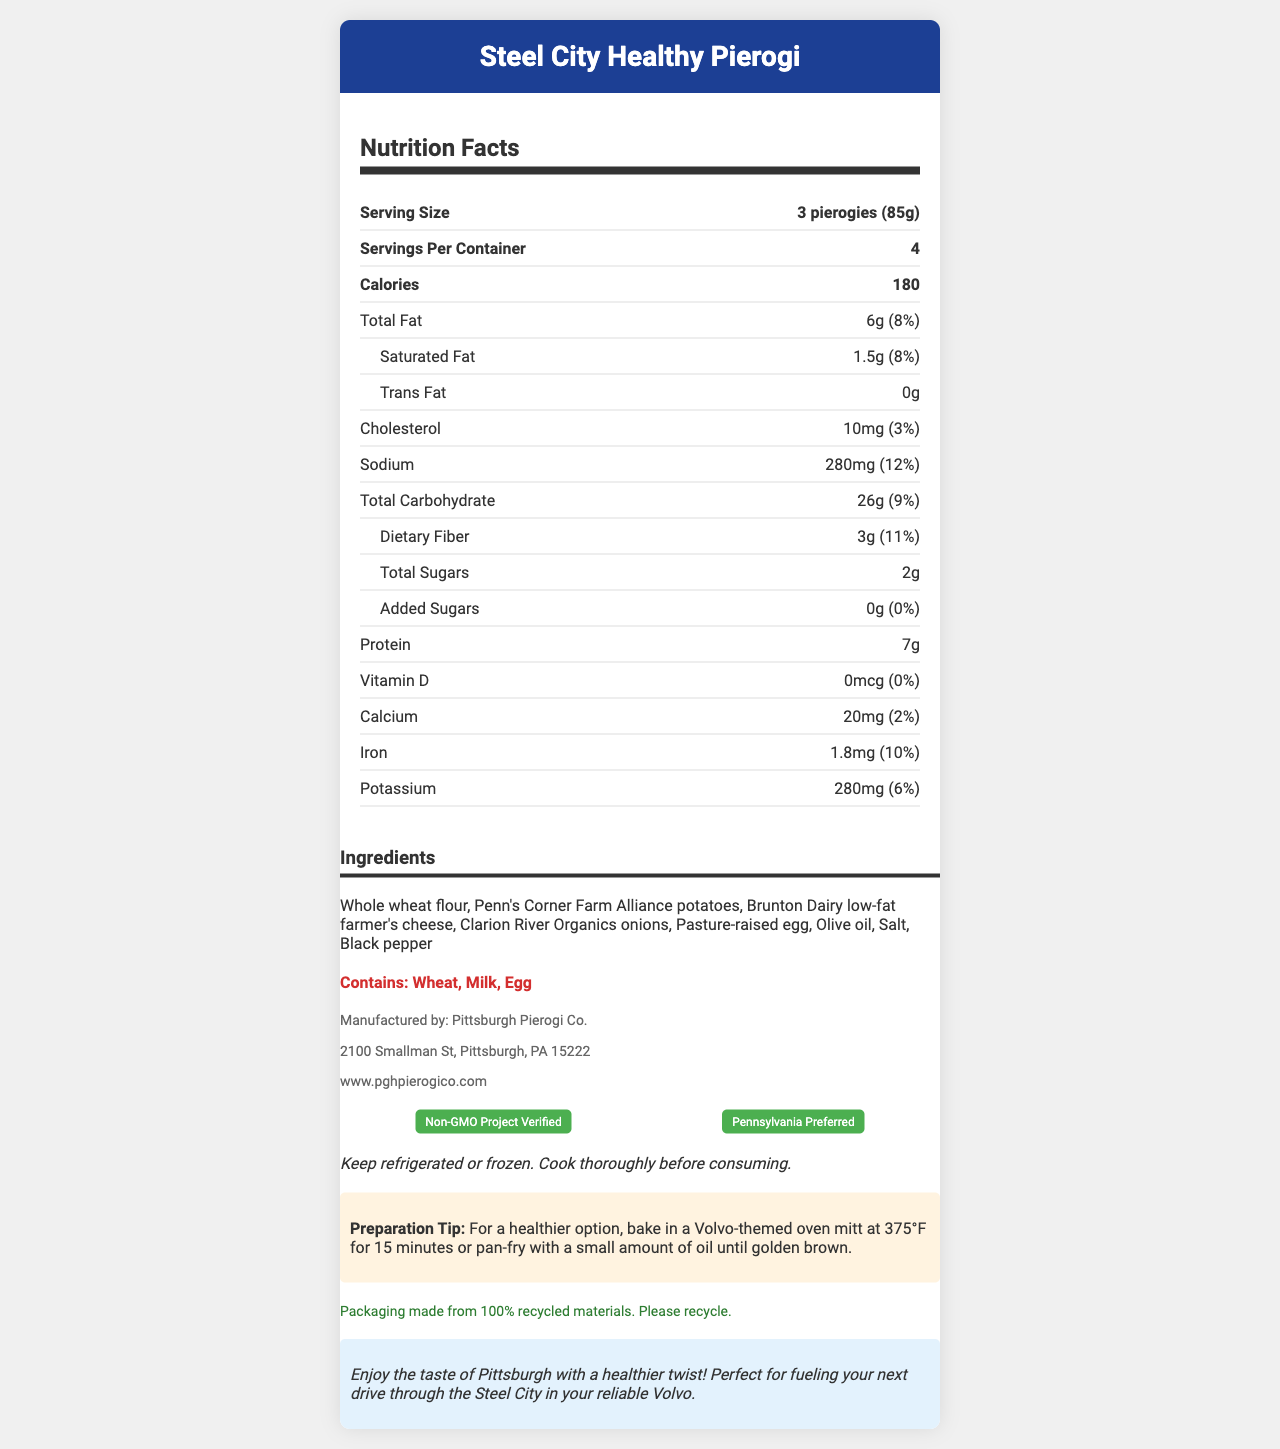what is the serving size of the Steel City Healthy Pierogi? The document specifies the serving size at the top of the nutrition facts section as "3 pierogies (85g)".
Answer: 3 pierogies (85g) How many calories are in one serving of the Steel City Healthy Pierogi? The number of calories per serving is listed as 180 in the nutrition facts section.
Answer: 180 What is the total fat content per serving? The total fat content per serving is indicated as 6g in the nutrition facts section.
Answer: 6g Which ingredient contributes to the protein content in these pierogies? The ingredients list includes Brunton Dairy low-fat farmer's cheese which is likely to contribute to the protein content.
Answer: Brunton Dairy low-fat farmer's cheese What allergens are present in the Steel City Healthy Pierogi? The allergens section of the document clearly states that the product contains Wheat, Milk, and Egg.
Answer: Wheat, Milk, Egg How many servings are there per container? The document lists the number of servings per container in the nutrition facts section as 4.
Answer: 4 What percentage of the daily value of dietary fiber does one serving provide? The document states that one serving provides 3g of dietary fiber, which is 11% of the daily value.
Answer: 11% How much cholesterol does one serving contain? The nutrition facts section lists cholesterol content as 10mg per serving.
Answer: 10mg How much added sugar is in one serving? The nutrition facts section lists the amount of added sugars as 0g.
Answer: 0g Which of the following is a certification held by the Steel City Healthy Pierogi? A. Organic Certified B. Fair Trade Certified C. Non-GMO Project Verified The document states that the product is Non-GMO Project Verified and Pennsylvania Preferred.
Answer: C. Non-GMO Project Verified What is the sodium content per serving? A. 250mg B. 280mg C. 200mg D. 300mg The nutrition facts section notes that one serving contains 280mg of sodium.
Answer: B. 280mg What is the recommended oven temperature for baking the pierogies for a healthier option? The preparation tips section recommends baking the pierogies at 375°F for a healthier option.
Answer: 375°F Is the Steel City Healthy Pierogi suitable for someone with a gluten allergy? The allergens section indicates that the product contains wheat, which is not suitable for someone with a gluten allergy.
Answer: No Summarize the main idea of the Steel City Healthy Pierogi document. The document focuses on presenting a detailed and appealing overview of the Steel City Healthy Pierogi, highlighting its nutritional value, local sourcing, health benefits, and eco-friendly packaging. It also includes preparation instructions and a promotional note related to enjoying Pittsburgh and driving a Volvo.
Answer: The document provides nutritional information and preparation instructions for the Steel City Healthy Pierogi, emphasizing its local Pittsburgh ingredients and health-conscious recipe. It includes details on serving size, calories, fat, carbohydrates, and protein, along with highlighted allergens and manufacturer details. The pierogi are certified non-GMO and promote sustainability with recyclable packaging. How many grams of saturated fat are in one serving? The nutrition facts section lists the saturated fat content per serving as 1.5g.
Answer: 1.5g Does the product packaging support sustainability? The sustainability note mentions that the packaging is made from 100% recycled materials and encourages consumers to recycle it.
Answer: Yes What is the manufacturer's website? The manufacturer info section lists the website as www.pghpierogico.com.
Answer: www.pghpierogico.com What is the amount of iron in one serving? The nutrition facts section states that one serving contains 1.8mg of iron.
Answer: 1.8mg Is there a discount if you purchase 3 containers of Steel City Healthy Pierogi? The document does not provide any information regarding discounts on purchasing multiple containers.
Answer: Cannot be determined 